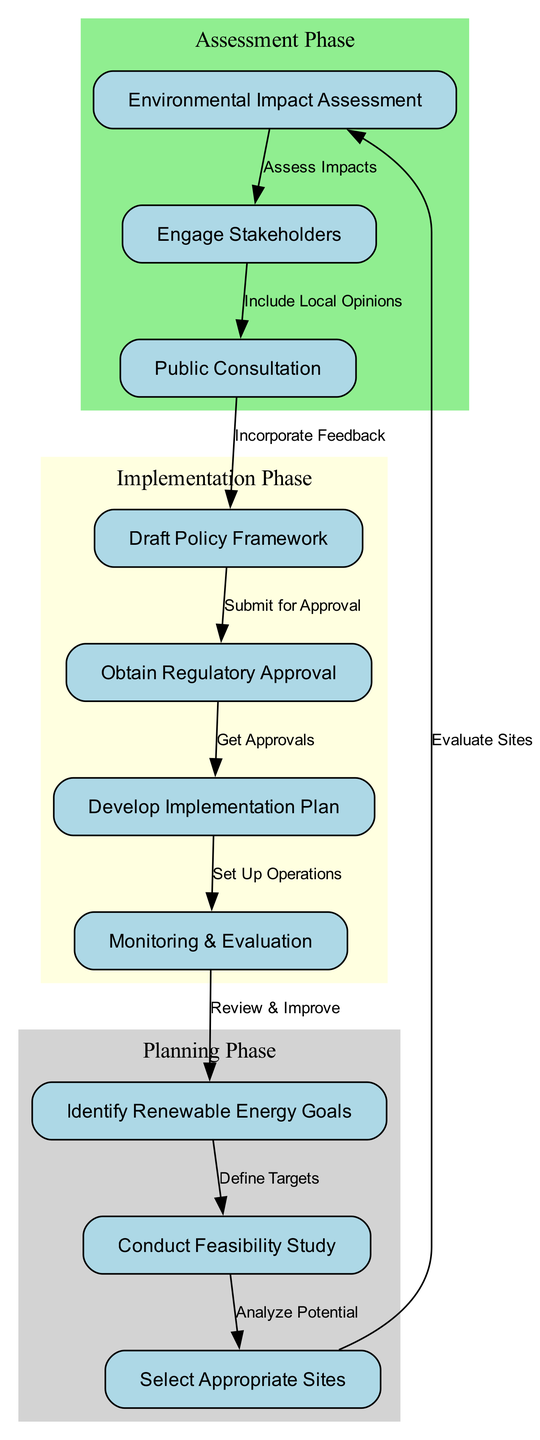What is the first step in the policy development process? The diagram starts with the node labeled "Identify Renewable Energy Goals," which is positioned at the top and signifies the initial action to be taken in the policy development process.
Answer: Identify Renewable Energy Goals How many nodes are there in the diagram? By counting each distinct labeled node in the diagram, we see that there are ten nodes represented.
Answer: 10 What relationship exists between conducting feasibility studies and selecting appropriate sites? The diagram shows a directed edge labeled "Analyze Potential" connecting the node "Conduct Feasibility Study" to the node "Select Appropriate Sites," indicating that conducting feasibility studies directly informs site selection.
Answer: Analyze Potential Which phase includes the "Environmental Impact Assessment"? The node "Environmental Impact Assessment" is grouped within the "Assessment Phase," as indicated by the surrounding light green shaded area in the diagram.
Answer: Assessment Phase What is the final stage of the process? The last node in the flowchart is "Monitoring & Evaluation," following the development of an implementation plan and refers to ongoing oversight after completing earlier steps.
Answer: Monitoring & Evaluation After the public consultation, which step comes next? The diagram depicts a directional flow from the "Public Consultation" node to the "Draft Policy Framework" node, indicating that drafting the policy follows public feedback.
Answer: Draft Policy Framework How many edges are there connecting the nodes? Examining the diagram, there are nine edges shown, each representing a unique relationship between steps in the development process.
Answer: 9 What process follows obtaining regulatory approval? The flowchart indicates that after obtaining regulatory approval, the next step is to "Develop Implementation Plan," showing the sequential order of actions.
Answer: Develop Implementation Plan What stakeholder engagement is suggested in the diagram? The node "Engage Stakeholders" points to the importance of stakeholder interaction, particularly following the "Environmental Impact Assessment," illustrating the need to include local opinions in the assessment process.
Answer: Include Local Opinions 